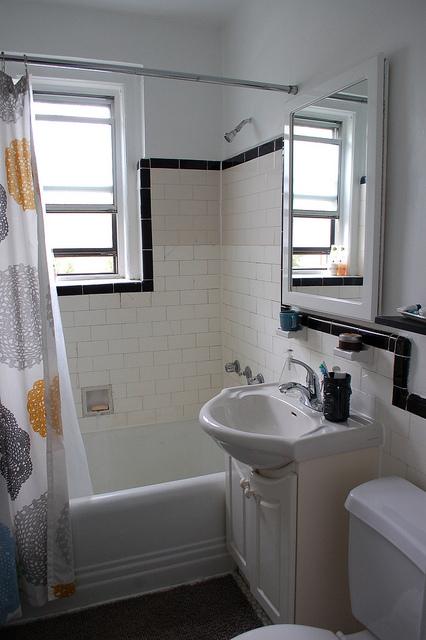Are the window open or closed?
Answer briefly. Open. What colors are on the shower curtain?
Give a very brief answer. Gray, yellow, black. Which decade do you believe this bathroom was built in?
Quick response, please. 1930s. What is the wall treatment on the back wall?
Keep it brief. Tile. 